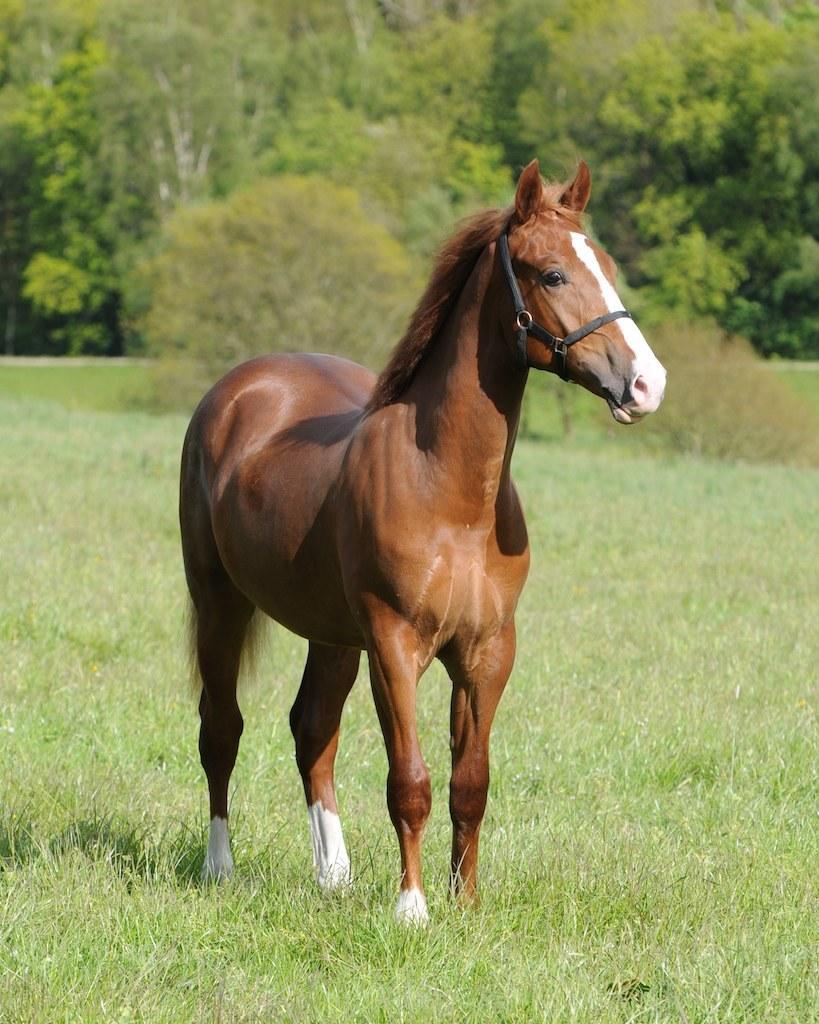Describe this image in one or two sentences. This image consists of a horse in brown color. At the bottom, there is green grass. In the background, there are trees and plants. 